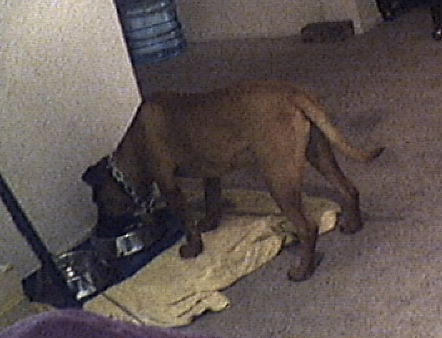Describe the objects in this image and their specific colors. I can see dog in darkgray, black, maroon, and gray tones, bottle in darkgray, gray, black, and darkblue tones, bowl in darkgray, black, and gray tones, and bowl in darkgray, black, and gray tones in this image. 